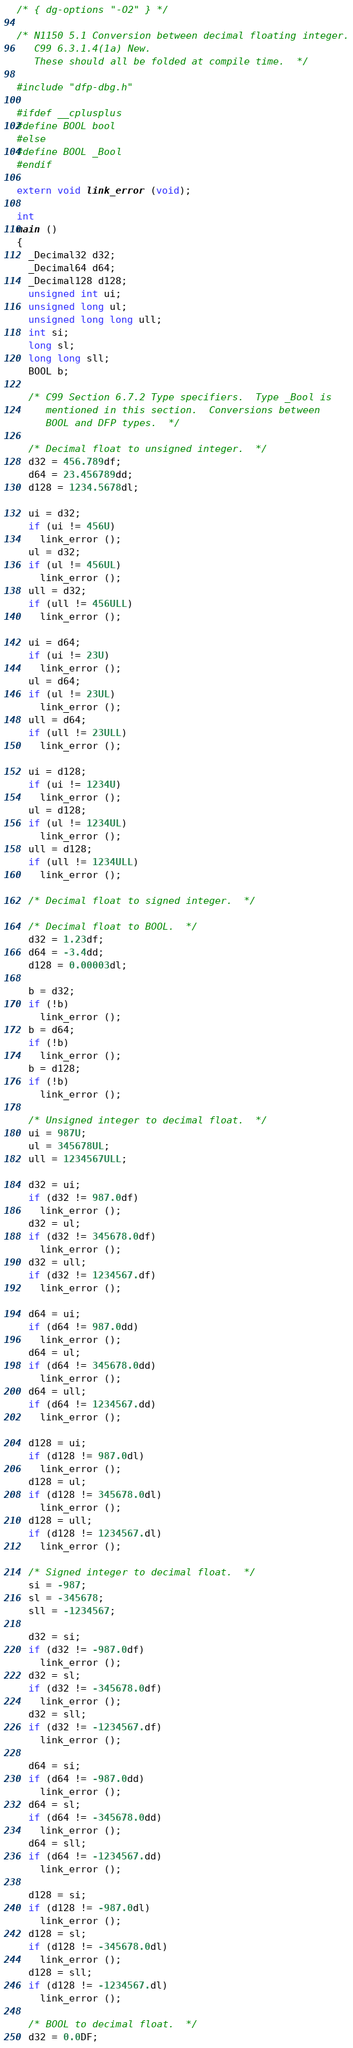<code> <loc_0><loc_0><loc_500><loc_500><_C_>/* { dg-options "-O2" } */

/* N1150 5.1 Conversion between decimal floating integer.
   C99 6.3.1.4(1a) New.
   These should all be folded at compile time.  */

#include "dfp-dbg.h"

#ifdef __cplusplus
#define BOOL bool
#else
#define BOOL _Bool
#endif

extern void link_error (void);

int
main ()
{
  _Decimal32 d32;
  _Decimal64 d64;
  _Decimal128 d128;
  unsigned int ui;
  unsigned long ul;
  unsigned long long ull;
  int si;
  long sl;
  long long sll;
  BOOL b;

  /* C99 Section 6.7.2 Type specifiers.  Type _Bool is 
     mentioned in this section.  Conversions between 
     BOOL and DFP types.  */

  /* Decimal float to unsigned integer.  */
  d32 = 456.789df;
  d64 = 23.456789dd;
  d128 = 1234.5678dl;

  ui = d32;
  if (ui != 456U)
    link_error ();
  ul = d32;
  if (ul != 456UL)
    link_error ();
  ull = d32;
  if (ull != 456ULL)
    link_error ();

  ui = d64;
  if (ui != 23U)
    link_error ();
  ul = d64;
  if (ul != 23UL)
    link_error ();
  ull = d64;
  if (ull != 23ULL)
    link_error ();

  ui = d128;
  if (ui != 1234U)
    link_error ();
  ul = d128;
  if (ul != 1234UL)
    link_error ();
  ull = d128;
  if (ull != 1234ULL)
    link_error ();

  /* Decimal float to signed integer.  */

  /* Decimal float to BOOL.  */
  d32 = 1.23df;
  d64 = -3.4dd;
  d128 = 0.00003dl;

  b = d32;
  if (!b)
    link_error ();
  b = d64;
  if (!b)
    link_error ();
  b = d128;
  if (!b)
    link_error ();

  /* Unsigned integer to decimal float.  */
  ui = 987U;
  ul = 345678UL;
  ull = 1234567ULL;

  d32 = ui;
  if (d32 != 987.0df)
    link_error ();
  d32 = ul;
  if (d32 != 345678.0df)
    link_error ();
  d32 = ull;
  if (d32 != 1234567.df)
    link_error ();

  d64 = ui;
  if (d64 != 987.0dd)
    link_error ();
  d64 = ul;
  if (d64 != 345678.0dd)
    link_error ();
  d64 = ull;
  if (d64 != 1234567.dd)
    link_error ();

  d128 = ui;
  if (d128 != 987.0dl)
    link_error ();
  d128 = ul;
  if (d128 != 345678.0dl)
    link_error ();
  d128 = ull;
  if (d128 != 1234567.dl)
    link_error ();

  /* Signed integer to decimal float.  */
  si = -987;
  sl = -345678;
  sll = -1234567;

  d32 = si;
  if (d32 != -987.0df)
    link_error ();
  d32 = sl;
  if (d32 != -345678.0df)
    link_error ();
  d32 = sll;
  if (d32 != -1234567.df)
    link_error ();

  d64 = si;
  if (d64 != -987.0dd)
    link_error ();
  d64 = sl;
  if (d64 != -345678.0dd)
    link_error ();
  d64 = sll;
  if (d64 != -1234567.dd)
    link_error ();

  d128 = si;
  if (d128 != -987.0dl)
    link_error ();
  d128 = sl;
  if (d128 != -345678.0dl)
    link_error ();
  d128 = sll;
  if (d128 != -1234567.dl)
    link_error ();

  /* BOOL to decimal float.  */
  d32 = 0.0DF;</code> 